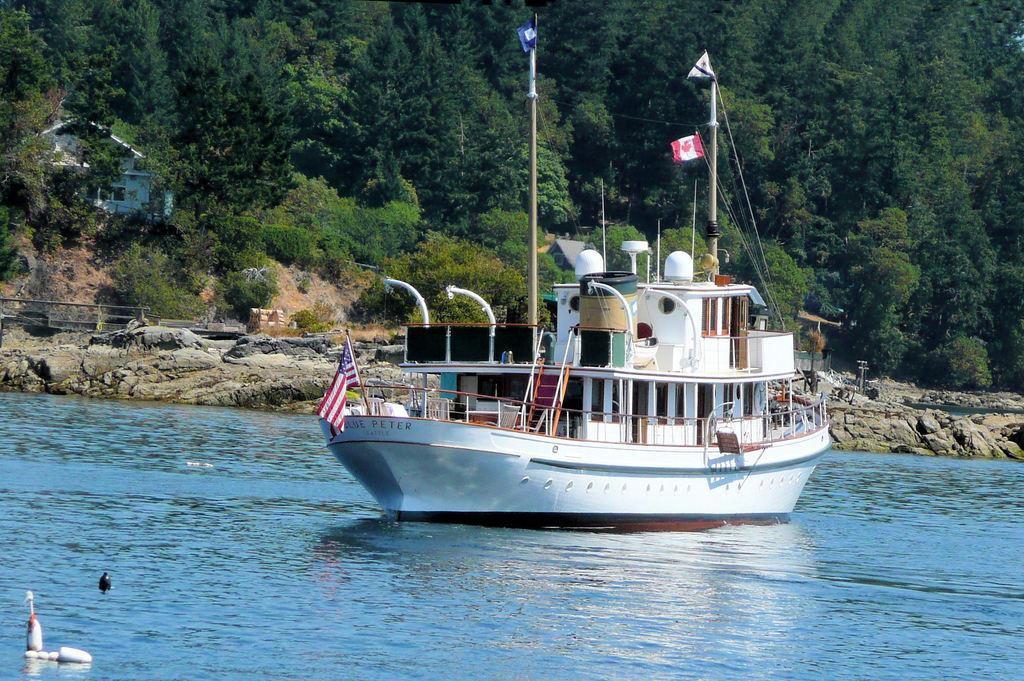<image>
Summarize the visual content of the image. A boat with Peter as part of its name is just off the rocky coast. 